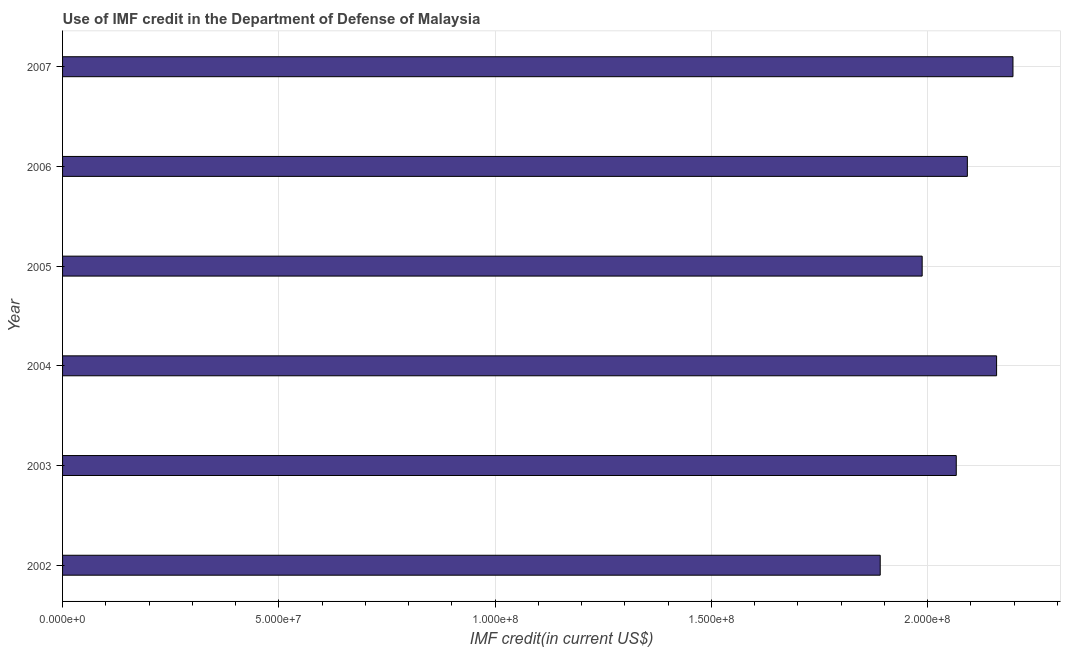Does the graph contain any zero values?
Make the answer very short. No. Does the graph contain grids?
Make the answer very short. Yes. What is the title of the graph?
Give a very brief answer. Use of IMF credit in the Department of Defense of Malaysia. What is the label or title of the X-axis?
Provide a succinct answer. IMF credit(in current US$). What is the use of imf credit in dod in 2007?
Offer a very short reply. 2.20e+08. Across all years, what is the maximum use of imf credit in dod?
Give a very brief answer. 2.20e+08. Across all years, what is the minimum use of imf credit in dod?
Offer a terse response. 1.89e+08. In which year was the use of imf credit in dod maximum?
Offer a very short reply. 2007. What is the sum of the use of imf credit in dod?
Offer a terse response. 1.24e+09. What is the difference between the use of imf credit in dod in 2005 and 2006?
Offer a terse response. -1.04e+07. What is the average use of imf credit in dod per year?
Make the answer very short. 2.07e+08. What is the median use of imf credit in dod?
Your answer should be very brief. 2.08e+08. Do a majority of the years between 2002 and 2006 (inclusive) have use of imf credit in dod greater than 50000000 US$?
Your answer should be very brief. Yes. What is the ratio of the use of imf credit in dod in 2002 to that in 2005?
Keep it short and to the point. 0.95. Is the difference between the use of imf credit in dod in 2002 and 2006 greater than the difference between any two years?
Make the answer very short. No. What is the difference between the highest and the second highest use of imf credit in dod?
Your answer should be very brief. 3.79e+06. Is the sum of the use of imf credit in dod in 2005 and 2006 greater than the maximum use of imf credit in dod across all years?
Provide a short and direct response. Yes. What is the difference between the highest and the lowest use of imf credit in dod?
Make the answer very short. 3.07e+07. In how many years, is the use of imf credit in dod greater than the average use of imf credit in dod taken over all years?
Offer a terse response. 4. How many bars are there?
Give a very brief answer. 6. How many years are there in the graph?
Provide a short and direct response. 6. What is the difference between two consecutive major ticks on the X-axis?
Offer a very short reply. 5.00e+07. Are the values on the major ticks of X-axis written in scientific E-notation?
Give a very brief answer. Yes. What is the IMF credit(in current US$) in 2002?
Make the answer very short. 1.89e+08. What is the IMF credit(in current US$) of 2003?
Your answer should be compact. 2.07e+08. What is the IMF credit(in current US$) in 2004?
Make the answer very short. 2.16e+08. What is the IMF credit(in current US$) in 2005?
Your answer should be very brief. 1.99e+08. What is the IMF credit(in current US$) of 2006?
Your answer should be compact. 2.09e+08. What is the IMF credit(in current US$) of 2007?
Keep it short and to the point. 2.20e+08. What is the difference between the IMF credit(in current US$) in 2002 and 2003?
Keep it short and to the point. -1.76e+07. What is the difference between the IMF credit(in current US$) in 2002 and 2004?
Make the answer very short. -2.69e+07. What is the difference between the IMF credit(in current US$) in 2002 and 2005?
Make the answer very short. -9.70e+06. What is the difference between the IMF credit(in current US$) in 2002 and 2006?
Provide a short and direct response. -2.01e+07. What is the difference between the IMF credit(in current US$) in 2002 and 2007?
Make the answer very short. -3.07e+07. What is the difference between the IMF credit(in current US$) in 2003 and 2004?
Provide a short and direct response. -9.32e+06. What is the difference between the IMF credit(in current US$) in 2003 and 2005?
Offer a very short reply. 7.88e+06. What is the difference between the IMF credit(in current US$) in 2003 and 2006?
Make the answer very short. -2.56e+06. What is the difference between the IMF credit(in current US$) in 2003 and 2007?
Make the answer very short. -1.31e+07. What is the difference between the IMF credit(in current US$) in 2004 and 2005?
Your answer should be compact. 1.72e+07. What is the difference between the IMF credit(in current US$) in 2004 and 2006?
Offer a very short reply. 6.76e+06. What is the difference between the IMF credit(in current US$) in 2004 and 2007?
Provide a succinct answer. -3.79e+06. What is the difference between the IMF credit(in current US$) in 2005 and 2006?
Offer a terse response. -1.04e+07. What is the difference between the IMF credit(in current US$) in 2005 and 2007?
Offer a terse response. -2.10e+07. What is the difference between the IMF credit(in current US$) in 2006 and 2007?
Your response must be concise. -1.05e+07. What is the ratio of the IMF credit(in current US$) in 2002 to that in 2003?
Offer a terse response. 0.92. What is the ratio of the IMF credit(in current US$) in 2002 to that in 2005?
Ensure brevity in your answer.  0.95. What is the ratio of the IMF credit(in current US$) in 2002 to that in 2006?
Offer a very short reply. 0.9. What is the ratio of the IMF credit(in current US$) in 2002 to that in 2007?
Offer a very short reply. 0.86. What is the ratio of the IMF credit(in current US$) in 2003 to that in 2004?
Ensure brevity in your answer.  0.96. What is the ratio of the IMF credit(in current US$) in 2003 to that in 2005?
Offer a very short reply. 1.04. What is the ratio of the IMF credit(in current US$) in 2003 to that in 2006?
Provide a short and direct response. 0.99. What is the ratio of the IMF credit(in current US$) in 2003 to that in 2007?
Offer a terse response. 0.94. What is the ratio of the IMF credit(in current US$) in 2004 to that in 2005?
Your answer should be compact. 1.09. What is the ratio of the IMF credit(in current US$) in 2004 to that in 2006?
Offer a terse response. 1.03. What is the ratio of the IMF credit(in current US$) in 2004 to that in 2007?
Ensure brevity in your answer.  0.98. What is the ratio of the IMF credit(in current US$) in 2005 to that in 2006?
Provide a short and direct response. 0.95. What is the ratio of the IMF credit(in current US$) in 2005 to that in 2007?
Your response must be concise. 0.9. What is the ratio of the IMF credit(in current US$) in 2006 to that in 2007?
Offer a very short reply. 0.95. 